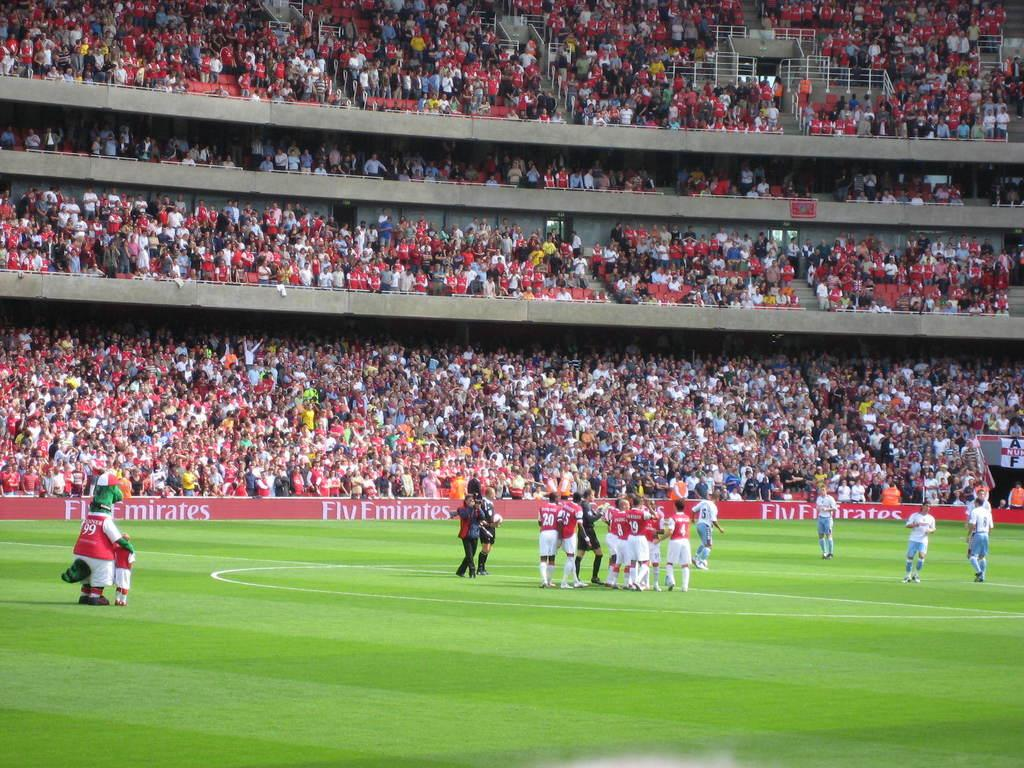<image>
Relay a brief, clear account of the picture shown. A stadium full of fans watch as the Fly Emirates take on a team in blue and white. 